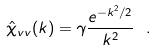<formula> <loc_0><loc_0><loc_500><loc_500>\hat { \chi } _ { v v } ( { k } ) = \gamma \frac { e ^ { - k ^ { 2 } / 2 } } { k ^ { 2 } } \ .</formula> 